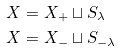<formula> <loc_0><loc_0><loc_500><loc_500>X & = X _ { + } \sqcup S _ { \lambda } \\ X & = X _ { - } \sqcup S _ { - \lambda }</formula> 